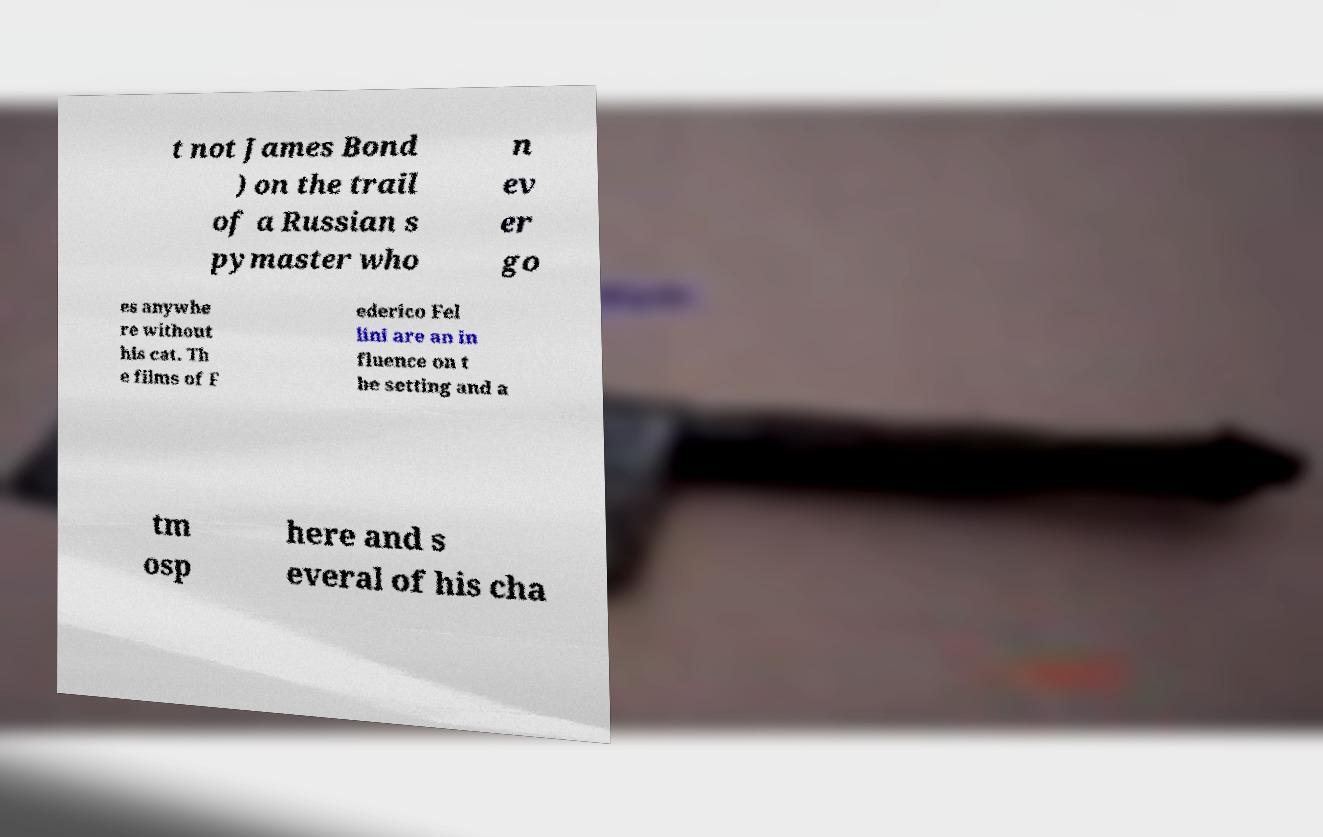Can you accurately transcribe the text from the provided image for me? t not James Bond ) on the trail of a Russian s pymaster who n ev er go es anywhe re without his cat. Th e films of F ederico Fel lini are an in fluence on t he setting and a tm osp here and s everal of his cha 